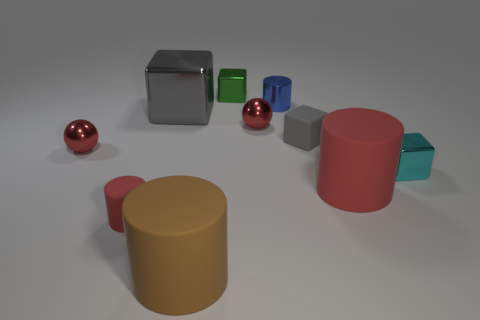The other cylinder that is the same color as the small matte cylinder is what size?
Your answer should be compact. Large. What shape is the object that is the same color as the large shiny block?
Your response must be concise. Cube. Is there any other thing that is the same color as the large metal cube?
Provide a short and direct response. Yes. Is the material of the small cylinder that is behind the big block the same as the tiny red thing to the left of the small red cylinder?
Ensure brevity in your answer.  Yes. What material is the thing that is behind the big gray metallic cube and on the right side of the green thing?
Offer a very short reply. Metal. Is the shape of the blue thing the same as the tiny matte thing left of the brown cylinder?
Ensure brevity in your answer.  Yes. What material is the cylinder right of the rubber thing behind the red cylinder that is on the right side of the blue metallic thing?
Keep it short and to the point. Rubber. How many other things are the same size as the rubber cube?
Keep it short and to the point. 6. Is the large cube the same color as the small rubber cube?
Keep it short and to the point. Yes. There is a tiny shiny cube on the right side of the big cylinder right of the tiny blue thing; what number of cylinders are in front of it?
Give a very brief answer. 3. 